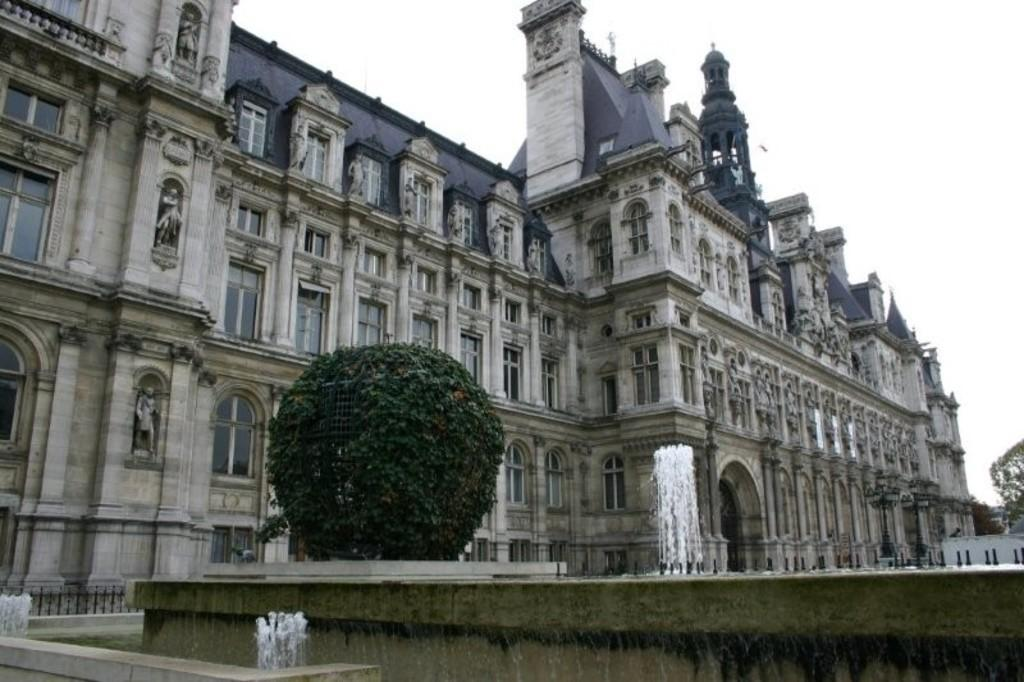What type of structure can be seen in the background of the image? There is a building in the background of the image. What other feature is present in the background of the image? There is a water fountain in the background of the image. Can you describe any vegetation in the image? There is a plant in the image. What is visible at the top of the image? The sky is visible at the top of the image. How does the lake contribute to the development of the area in the image? There is no lake present in the image; it features a building, a water fountain, a plant, and the sky. What type of motion can be observed in the water fountain in the image? The water fountain is not shown in motion in the image; it is a still image. 